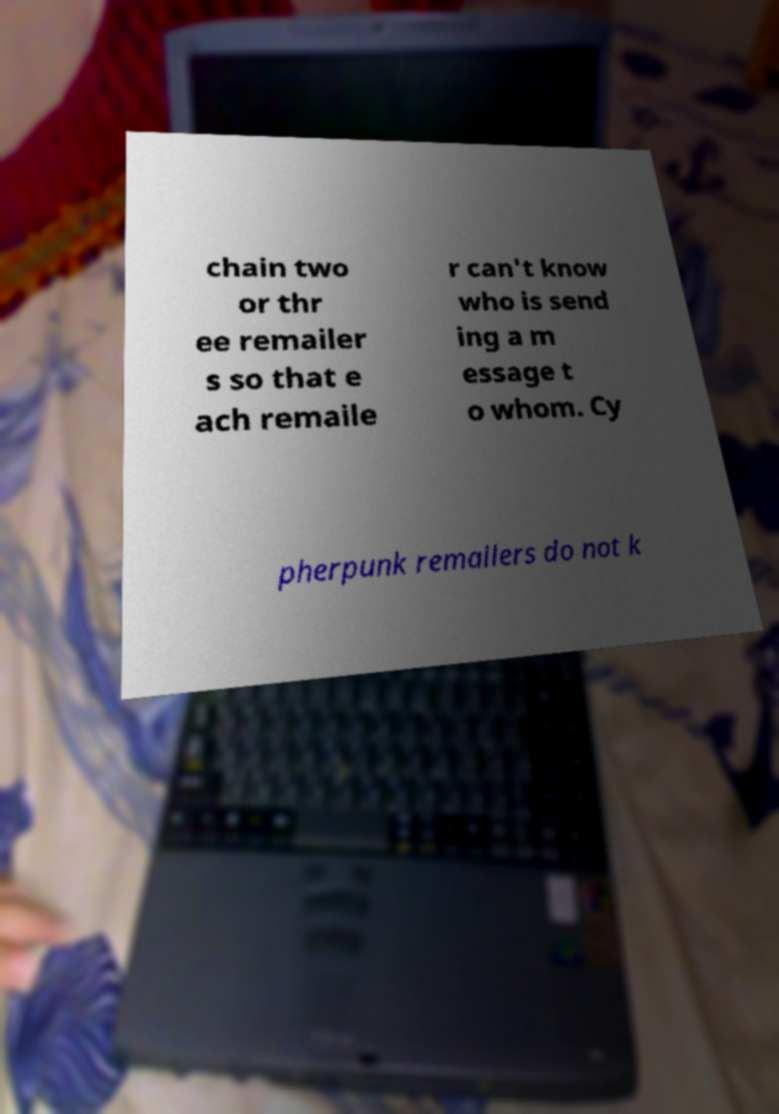I need the written content from this picture converted into text. Can you do that? chain two or thr ee remailer s so that e ach remaile r can't know who is send ing a m essage t o whom. Cy pherpunk remailers do not k 